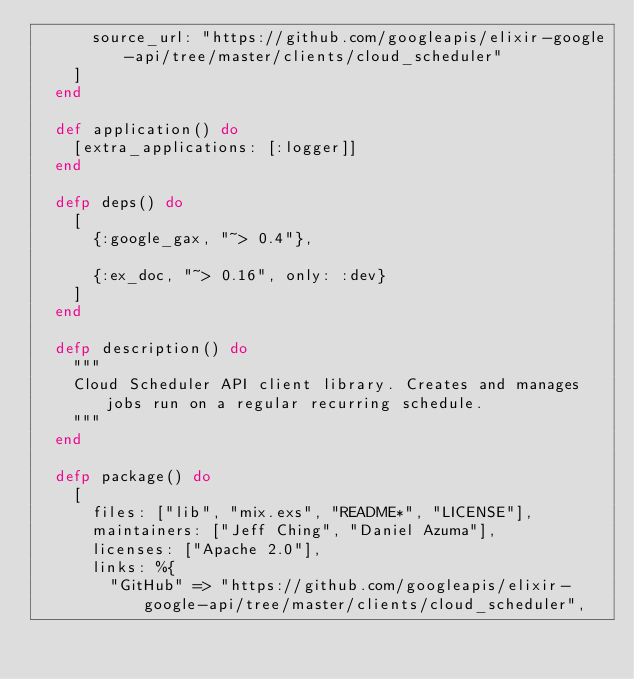Convert code to text. <code><loc_0><loc_0><loc_500><loc_500><_Elixir_>      source_url: "https://github.com/googleapis/elixir-google-api/tree/master/clients/cloud_scheduler"
    ]
  end

  def application() do
    [extra_applications: [:logger]]
  end

  defp deps() do
    [
      {:google_gax, "~> 0.4"},

      {:ex_doc, "~> 0.16", only: :dev}
    ]
  end

  defp description() do
    """
    Cloud Scheduler API client library. Creates and manages jobs run on a regular recurring schedule.
    """
  end

  defp package() do
    [
      files: ["lib", "mix.exs", "README*", "LICENSE"],
      maintainers: ["Jeff Ching", "Daniel Azuma"],
      licenses: ["Apache 2.0"],
      links: %{
        "GitHub" => "https://github.com/googleapis/elixir-google-api/tree/master/clients/cloud_scheduler",</code> 